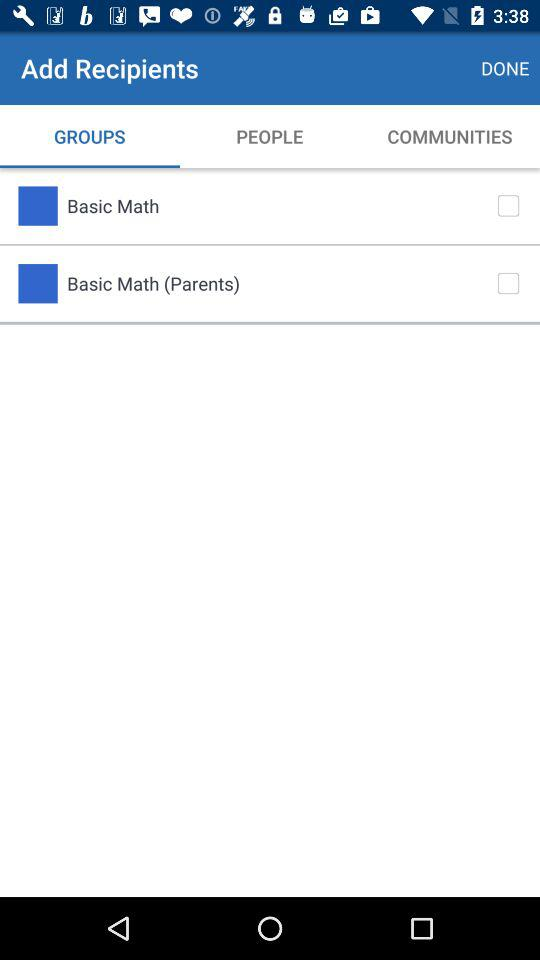What is the status of "Basic Math"? The status of "Basic Math" is "off". 